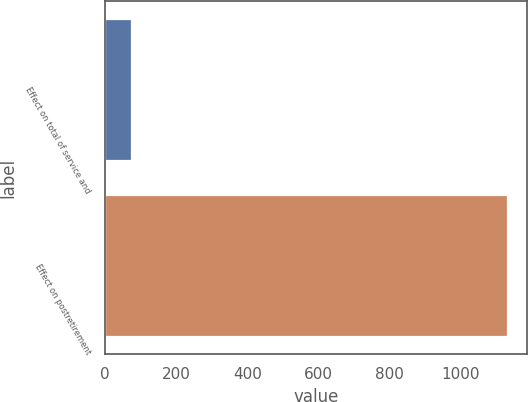Convert chart to OTSL. <chart><loc_0><loc_0><loc_500><loc_500><bar_chart><fcel>Effect on total of service and<fcel>Effect on postretirement<nl><fcel>74<fcel>1131<nl></chart> 